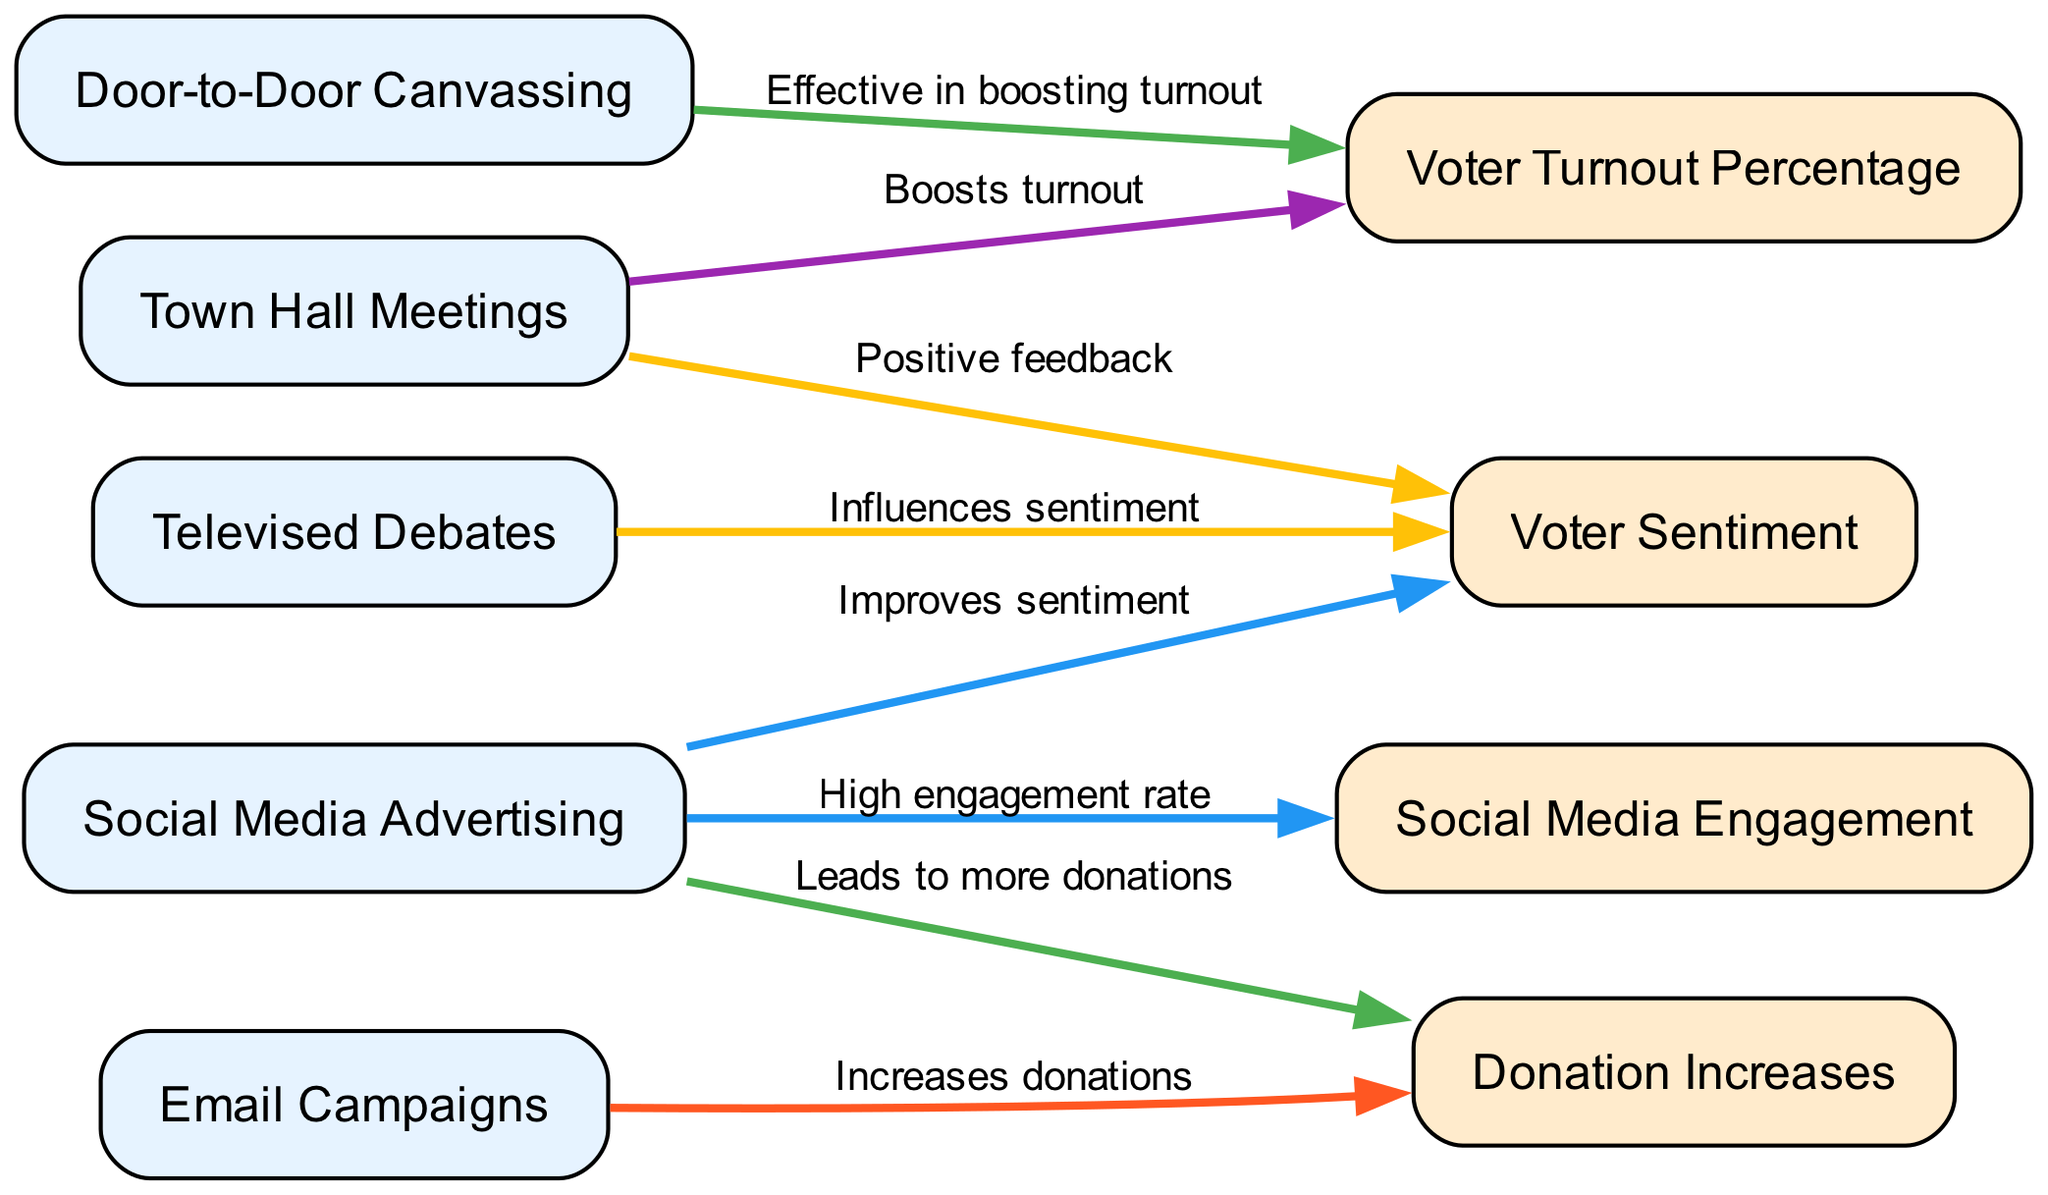What are the nodes representing campaign strategies? The nodes representing campaign strategies are Door-to-Door Canvassing, Social Media Advertising, Televised Debates, Town Hall Meetings, and Email Campaigns.
Answer: Door-to-Door Canvassing, Social Media Advertising, Televised Debates, Town Hall Meetings, Email Campaigns Which strategy leads to the highest voter turnout? Both Door-to-Door Canvassing and Town Hall Meetings lead to increases in voter turnout as indicated by their connections to the Voter Turnout Percentage node.
Answer: Door-to-Door Canvassing and Town Hall Meetings What performance metric is influenced by Televised Debates? Televised Debates influence Voter Sentiment, indicating its effectiveness in shaping how voters feel about the candidate.
Answer: Voter Sentiment How many edges are represented in the diagram? The diagram includes a total of 7 edges, each representing a connection between a campaign strategy and its impact on performance metrics.
Answer: 7 Which campaign strategy has a high engagement rate? Social Media Advertising has a high engagement rate as indicated by its connection to Social Media Engagement.
Answer: Social Media Advertising Which metric is directly linked to both Email Campaigns and Social Media Advertising? Donation Increases is directly linked to both Email Campaigns and Social Media Advertising, showing a correlation between these strategies and increased donations.
Answer: Donation Increases How does Town Hall Meetings impact Voter Sentiment? Town Hall Meetings yield positive feedback, which links directly to Voter Sentiment, indicating a favorable perception from attendees.
Answer: Positive feedback Which strategy is associated with both increases in donations and improvements in sentiment? Social Media Advertising is associated with both increases in donations and improvements in sentiment, as it connects to both Donation Increases and Voter Sentiment.
Answer: Social Media Advertising 